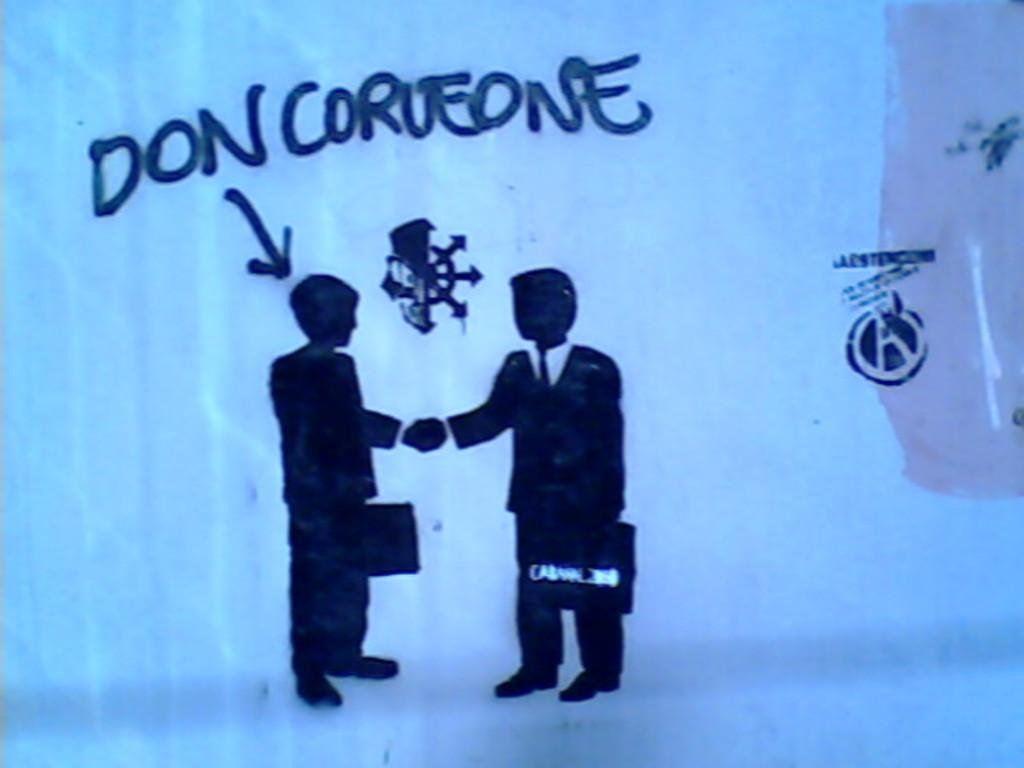<image>
Write a terse but informative summary of the picture. A painting on a wall says Don Corleone. 